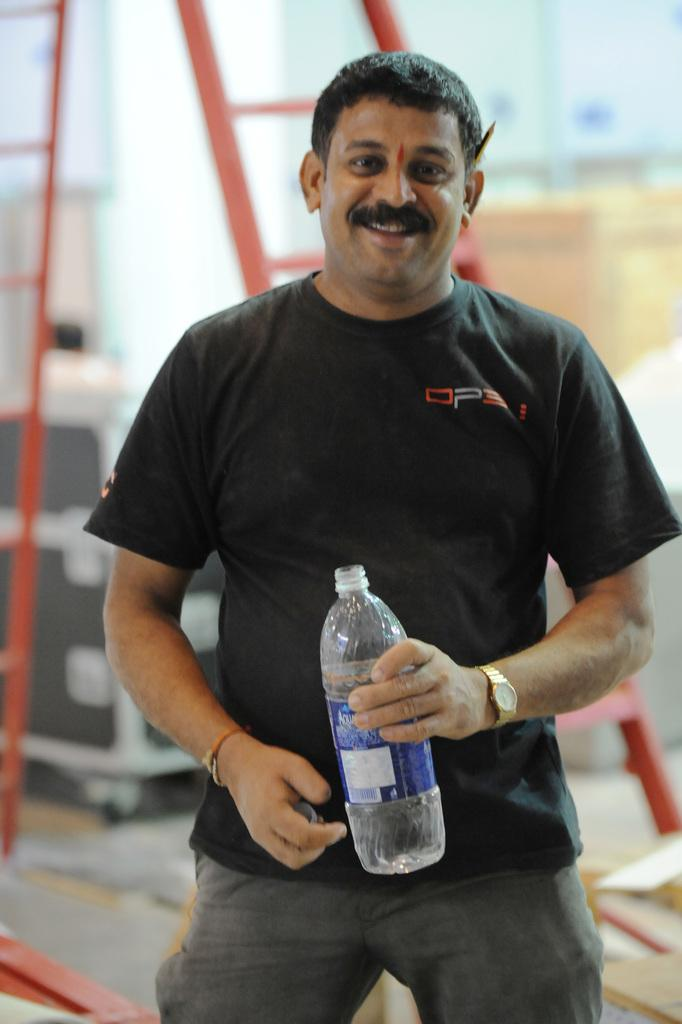What is the person in the image doing? There is a person standing in the image. What is the person wearing? The person is wearing a black t-shirt. What object is the person holding in the image? The person is holding a water bottle in his hand. What can be seen behind the person? There is a ladder visible behind the person. What type of guitar is the person playing in the image? There is no guitar present in the image; the person is holding a water bottle. 